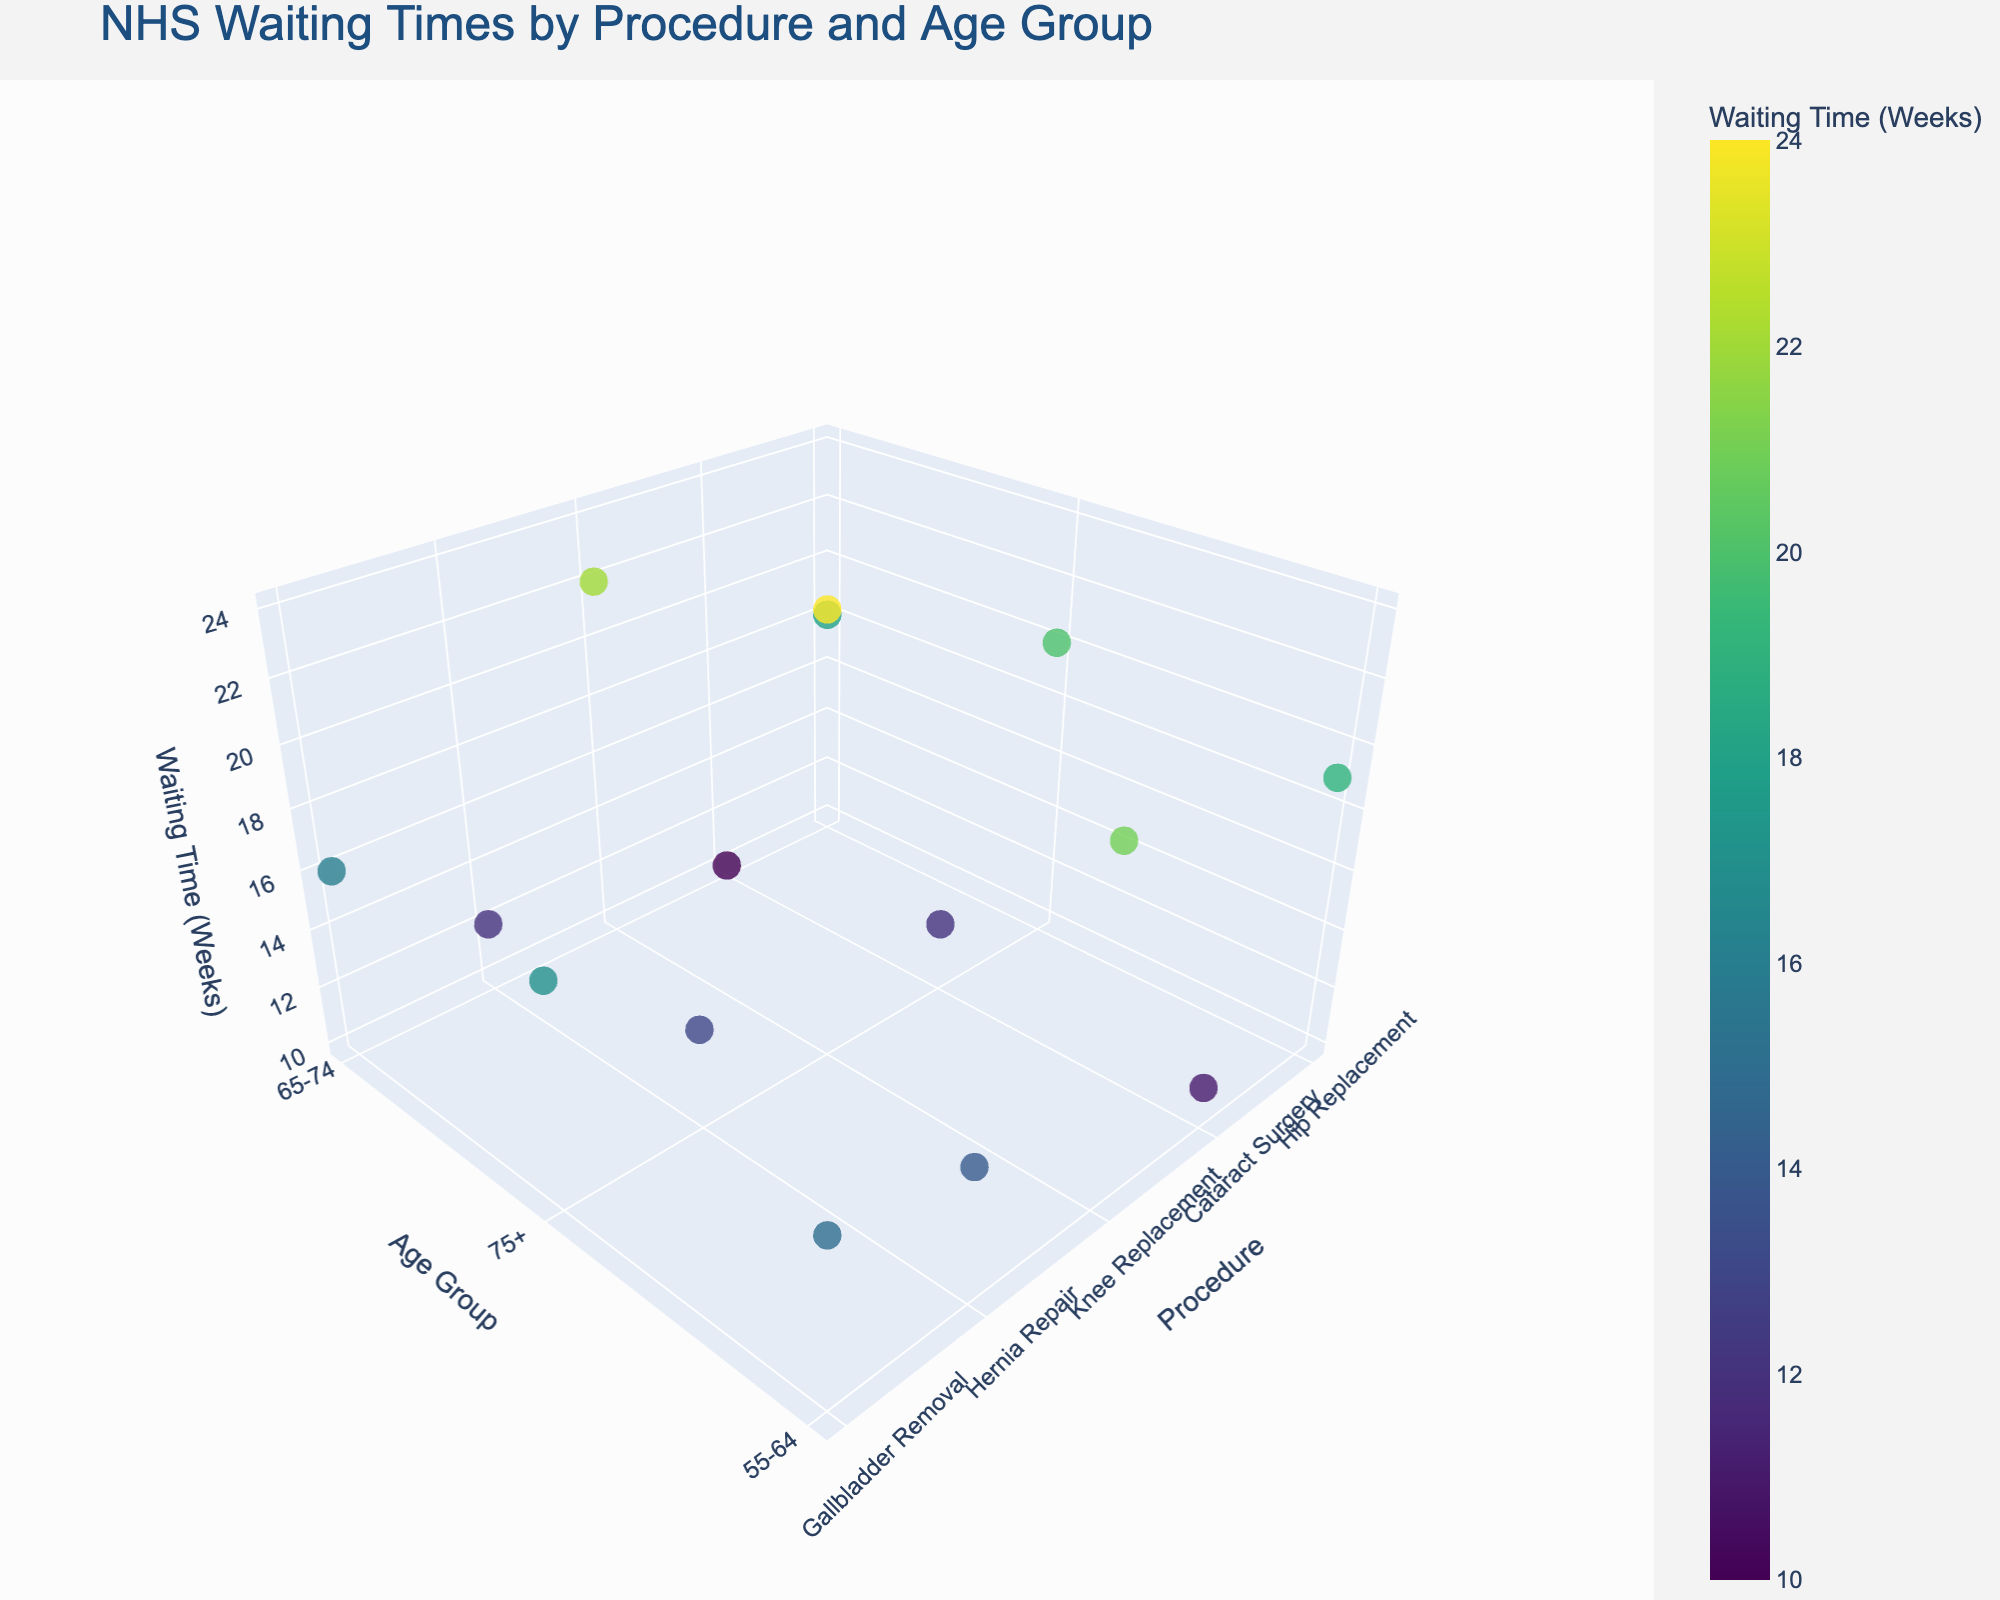What is the title of the plot? The title of the plot is centered at the top and provides an overview of the figure. It is written in a large font to be easily noticeable.
Answer: NHS Waiting Times by Procedure and Age Group How is waiting time color-coded in the plot? Waiting time is indicated by colors on a color scale called 'Viridis,' where different shades represent various waiting times. The color bar on the right side of the figure illustrates this.
Answer: By color shades on a 'Viridis' scale Which procedure has the longest waiting time and at which hospital? By observing the highest point on the 'Waiting Time (Weeks)' axis and identifying the other parameters, we find that the highest waiting time recorded is for Knee Replacement in the Newcastle upon Tyne Hospitals.
Answer: Knee Replacement at Newcastle upon Tyne Hospitals What is the waiting time range for Cataract Surgery? Check all data points related to Cataract Surgery and observe their 'Waiting Time (Weeks).' The waiting times range from 10 to 12 weeks.
Answer: 10 to 12 weeks Which age group has the longest waiting time for Gallbladder Removal? Examine the data points for Gallbladder Removal and compare their 'Waiting Time (Weeks).' The longest wait time occurs for the 75+ age group at Sheffield Teaching Hospitals.
Answer: 75+ age group How does the waiting time for Hernia Repair vary with age group? Check the Hernia Repair data points to see how 'Waiting Time (Weeks)' changes across age groups: 55-64, 65-74, and 75+. The wait times are 14, 12, and 13 weeks, respectively.
Answer: Varies between 12 to 14 weeks depending on the age group What is the average waiting time for Hip Replacement across all hospitals? Note down the waiting times for Hip Replacement: 18, 20, and 19 weeks. Sum these values and divide by 3. Calculation: (18 + 20 + 19) / 3 = 57 / 3 = 19 weeks.
Answer: 19 weeks How does the waiting time for Cataract Surgery at Manchester Royal Infirmary compare with Addenbrooke’s Hospital? Compare the data points for Cataract Surgery at the two hospitals. Manchester Royal Infirmary has a 12-week wait, and Addenbrooke's Hospital has a 10-week wait.
Answer: Manchester Royal Infirmary has a longer wait by 2 weeks Which procedure at the age group 65-74 has the shortest waiting time? Look at the data points for the 65-74 age group and find the minimum 'Waiting Time (Weeks).' The shortest waiting time is 10 weeks for Cataract Surgery at Addenbrooke's Hospital.
Answer: Cataract Surgery at Addenbrooke's Hospital 